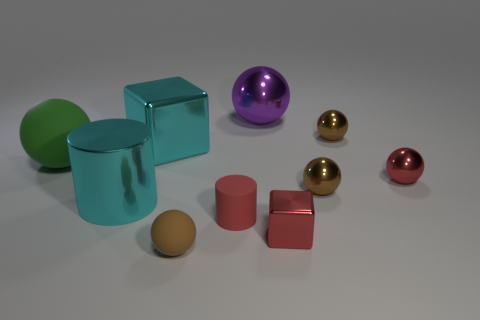Subtract all purple cylinders. How many brown balls are left? 3 Subtract all red spheres. How many spheres are left? 5 Subtract all purple spheres. How many spheres are left? 5 Subtract 4 balls. How many balls are left? 2 Subtract all cyan balls. Subtract all cyan cylinders. How many balls are left? 6 Subtract all spheres. How many objects are left? 4 Subtract all small red cylinders. Subtract all rubber things. How many objects are left? 6 Add 2 red metallic objects. How many red metallic objects are left? 4 Add 1 small gray shiny cubes. How many small gray shiny cubes exist? 1 Subtract 0 green blocks. How many objects are left? 10 